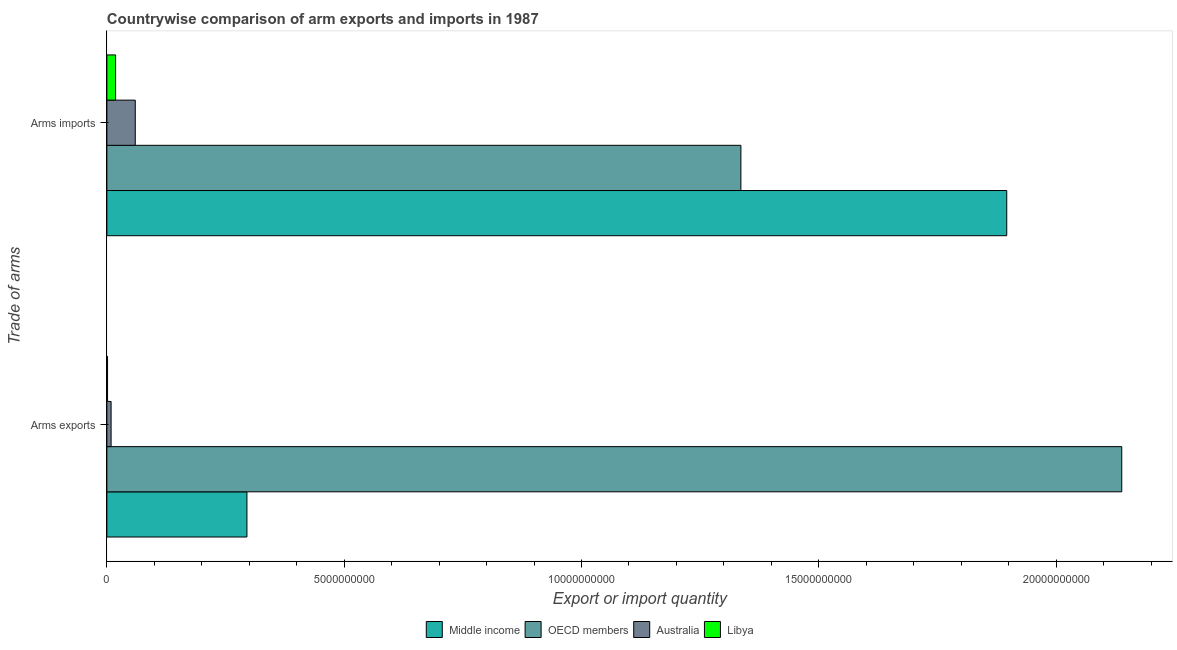Are the number of bars per tick equal to the number of legend labels?
Offer a very short reply. Yes. Are the number of bars on each tick of the Y-axis equal?
Provide a short and direct response. Yes. What is the label of the 2nd group of bars from the top?
Offer a terse response. Arms exports. What is the arms imports in Middle income?
Keep it short and to the point. 1.90e+1. Across all countries, what is the maximum arms imports?
Keep it short and to the point. 1.90e+1. Across all countries, what is the minimum arms imports?
Keep it short and to the point. 1.84e+08. In which country was the arms exports maximum?
Provide a short and direct response. OECD members. In which country was the arms exports minimum?
Offer a very short reply. Libya. What is the total arms exports in the graph?
Offer a terse response. 2.44e+1. What is the difference between the arms imports in OECD members and that in Libya?
Ensure brevity in your answer.  1.32e+1. What is the difference between the arms imports in Australia and the arms exports in Middle income?
Ensure brevity in your answer.  -2.35e+09. What is the average arms imports per country?
Give a very brief answer. 8.27e+09. What is the difference between the arms imports and arms exports in Libya?
Offer a very short reply. 1.70e+08. In how many countries, is the arms imports greater than 11000000000 ?
Your answer should be compact. 2. What is the ratio of the arms exports in Middle income to that in Australia?
Provide a short and direct response. 33.16. Is the arms exports in Libya less than that in Australia?
Ensure brevity in your answer.  Yes. In how many countries, is the arms exports greater than the average arms exports taken over all countries?
Offer a terse response. 1. What does the 3rd bar from the top in Arms exports represents?
Give a very brief answer. OECD members. What does the 3rd bar from the bottom in Arms imports represents?
Provide a short and direct response. Australia. How many bars are there?
Keep it short and to the point. 8. How many countries are there in the graph?
Provide a succinct answer. 4. Where does the legend appear in the graph?
Ensure brevity in your answer.  Bottom center. How are the legend labels stacked?
Offer a very short reply. Horizontal. What is the title of the graph?
Your answer should be very brief. Countrywise comparison of arm exports and imports in 1987. Does "Small states" appear as one of the legend labels in the graph?
Make the answer very short. No. What is the label or title of the X-axis?
Your answer should be very brief. Export or import quantity. What is the label or title of the Y-axis?
Ensure brevity in your answer.  Trade of arms. What is the Export or import quantity of Middle income in Arms exports?
Provide a short and direct response. 2.95e+09. What is the Export or import quantity in OECD members in Arms exports?
Your response must be concise. 2.14e+1. What is the Export or import quantity of Australia in Arms exports?
Your answer should be compact. 8.90e+07. What is the Export or import quantity in Libya in Arms exports?
Provide a short and direct response. 1.40e+07. What is the Export or import quantity in Middle income in Arms imports?
Provide a succinct answer. 1.90e+1. What is the Export or import quantity in OECD members in Arms imports?
Ensure brevity in your answer.  1.34e+1. What is the Export or import quantity in Australia in Arms imports?
Offer a terse response. 5.98e+08. What is the Export or import quantity of Libya in Arms imports?
Ensure brevity in your answer.  1.84e+08. Across all Trade of arms, what is the maximum Export or import quantity of Middle income?
Your response must be concise. 1.90e+1. Across all Trade of arms, what is the maximum Export or import quantity of OECD members?
Provide a succinct answer. 2.14e+1. Across all Trade of arms, what is the maximum Export or import quantity in Australia?
Make the answer very short. 5.98e+08. Across all Trade of arms, what is the maximum Export or import quantity in Libya?
Your answer should be compact. 1.84e+08. Across all Trade of arms, what is the minimum Export or import quantity in Middle income?
Make the answer very short. 2.95e+09. Across all Trade of arms, what is the minimum Export or import quantity in OECD members?
Provide a succinct answer. 1.34e+1. Across all Trade of arms, what is the minimum Export or import quantity in Australia?
Keep it short and to the point. 8.90e+07. Across all Trade of arms, what is the minimum Export or import quantity of Libya?
Give a very brief answer. 1.40e+07. What is the total Export or import quantity in Middle income in the graph?
Offer a very short reply. 2.19e+1. What is the total Export or import quantity in OECD members in the graph?
Keep it short and to the point. 3.47e+1. What is the total Export or import quantity of Australia in the graph?
Give a very brief answer. 6.87e+08. What is the total Export or import quantity in Libya in the graph?
Offer a terse response. 1.98e+08. What is the difference between the Export or import quantity of Middle income in Arms exports and that in Arms imports?
Offer a very short reply. -1.60e+1. What is the difference between the Export or import quantity of OECD members in Arms exports and that in Arms imports?
Make the answer very short. 8.02e+09. What is the difference between the Export or import quantity in Australia in Arms exports and that in Arms imports?
Offer a terse response. -5.09e+08. What is the difference between the Export or import quantity of Libya in Arms exports and that in Arms imports?
Offer a terse response. -1.70e+08. What is the difference between the Export or import quantity in Middle income in Arms exports and the Export or import quantity in OECD members in Arms imports?
Your answer should be compact. -1.04e+1. What is the difference between the Export or import quantity of Middle income in Arms exports and the Export or import quantity of Australia in Arms imports?
Give a very brief answer. 2.35e+09. What is the difference between the Export or import quantity of Middle income in Arms exports and the Export or import quantity of Libya in Arms imports?
Your answer should be very brief. 2.77e+09. What is the difference between the Export or import quantity of OECD members in Arms exports and the Export or import quantity of Australia in Arms imports?
Offer a terse response. 2.08e+1. What is the difference between the Export or import quantity of OECD members in Arms exports and the Export or import quantity of Libya in Arms imports?
Give a very brief answer. 2.12e+1. What is the difference between the Export or import quantity in Australia in Arms exports and the Export or import quantity in Libya in Arms imports?
Keep it short and to the point. -9.50e+07. What is the average Export or import quantity in Middle income per Trade of arms?
Provide a short and direct response. 1.10e+1. What is the average Export or import quantity in OECD members per Trade of arms?
Your response must be concise. 1.74e+1. What is the average Export or import quantity in Australia per Trade of arms?
Provide a succinct answer. 3.44e+08. What is the average Export or import quantity of Libya per Trade of arms?
Keep it short and to the point. 9.90e+07. What is the difference between the Export or import quantity in Middle income and Export or import quantity in OECD members in Arms exports?
Ensure brevity in your answer.  -1.84e+1. What is the difference between the Export or import quantity of Middle income and Export or import quantity of Australia in Arms exports?
Ensure brevity in your answer.  2.86e+09. What is the difference between the Export or import quantity of Middle income and Export or import quantity of Libya in Arms exports?
Your answer should be very brief. 2.94e+09. What is the difference between the Export or import quantity of OECD members and Export or import quantity of Australia in Arms exports?
Ensure brevity in your answer.  2.13e+1. What is the difference between the Export or import quantity of OECD members and Export or import quantity of Libya in Arms exports?
Keep it short and to the point. 2.14e+1. What is the difference between the Export or import quantity of Australia and Export or import quantity of Libya in Arms exports?
Offer a very short reply. 7.50e+07. What is the difference between the Export or import quantity in Middle income and Export or import quantity in OECD members in Arms imports?
Offer a terse response. 5.60e+09. What is the difference between the Export or import quantity in Middle income and Export or import quantity in Australia in Arms imports?
Provide a short and direct response. 1.84e+1. What is the difference between the Export or import quantity in Middle income and Export or import quantity in Libya in Arms imports?
Give a very brief answer. 1.88e+1. What is the difference between the Export or import quantity of OECD members and Export or import quantity of Australia in Arms imports?
Your answer should be very brief. 1.28e+1. What is the difference between the Export or import quantity of OECD members and Export or import quantity of Libya in Arms imports?
Provide a succinct answer. 1.32e+1. What is the difference between the Export or import quantity of Australia and Export or import quantity of Libya in Arms imports?
Your answer should be very brief. 4.14e+08. What is the ratio of the Export or import quantity in Middle income in Arms exports to that in Arms imports?
Make the answer very short. 0.16. What is the ratio of the Export or import quantity in OECD members in Arms exports to that in Arms imports?
Provide a short and direct response. 1.6. What is the ratio of the Export or import quantity of Australia in Arms exports to that in Arms imports?
Give a very brief answer. 0.15. What is the ratio of the Export or import quantity in Libya in Arms exports to that in Arms imports?
Your response must be concise. 0.08. What is the difference between the highest and the second highest Export or import quantity in Middle income?
Offer a terse response. 1.60e+1. What is the difference between the highest and the second highest Export or import quantity in OECD members?
Your answer should be very brief. 8.02e+09. What is the difference between the highest and the second highest Export or import quantity of Australia?
Offer a very short reply. 5.09e+08. What is the difference between the highest and the second highest Export or import quantity in Libya?
Ensure brevity in your answer.  1.70e+08. What is the difference between the highest and the lowest Export or import quantity of Middle income?
Offer a terse response. 1.60e+1. What is the difference between the highest and the lowest Export or import quantity in OECD members?
Provide a succinct answer. 8.02e+09. What is the difference between the highest and the lowest Export or import quantity of Australia?
Your answer should be very brief. 5.09e+08. What is the difference between the highest and the lowest Export or import quantity in Libya?
Offer a terse response. 1.70e+08. 